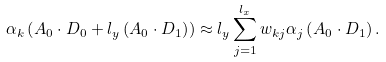<formula> <loc_0><loc_0><loc_500><loc_500>\alpha _ { k } \left ( A _ { 0 } \cdot D _ { 0 } + l _ { y } \left ( A _ { 0 } \cdot D _ { 1 } \right ) \right ) \approx l _ { y } \sum _ { j = 1 } ^ { l _ { x } } w _ { k j } \alpha _ { j } \left ( A _ { 0 } \cdot D _ { 1 } \right ) .</formula> 